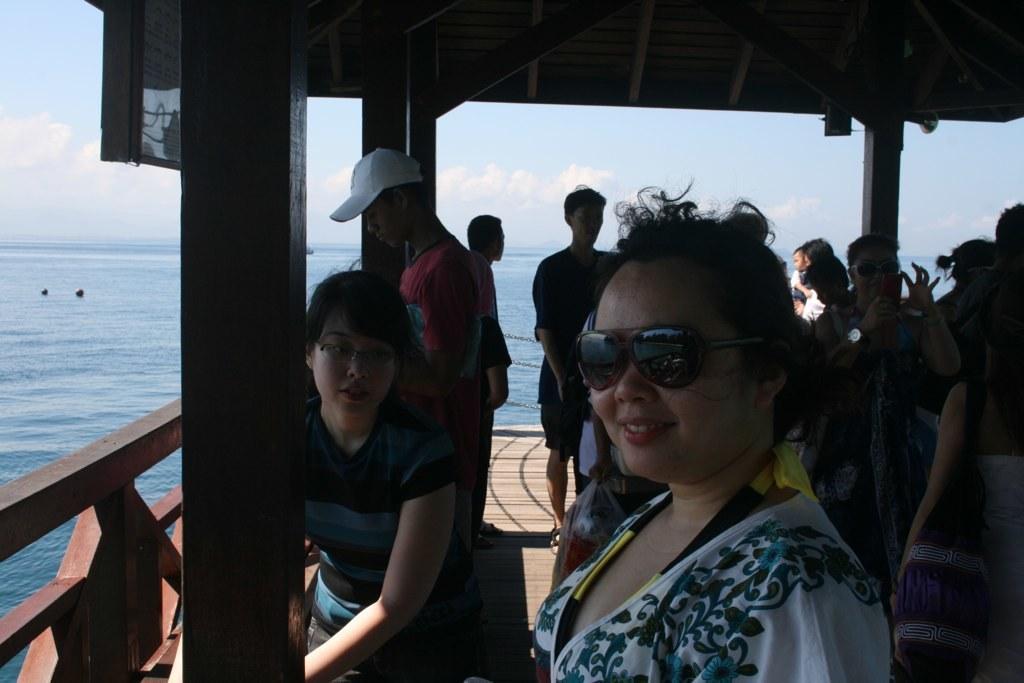Describe this image in one or two sentences. Here we can see group of people and there is a board. This is water. In the background there is sky with clouds. 